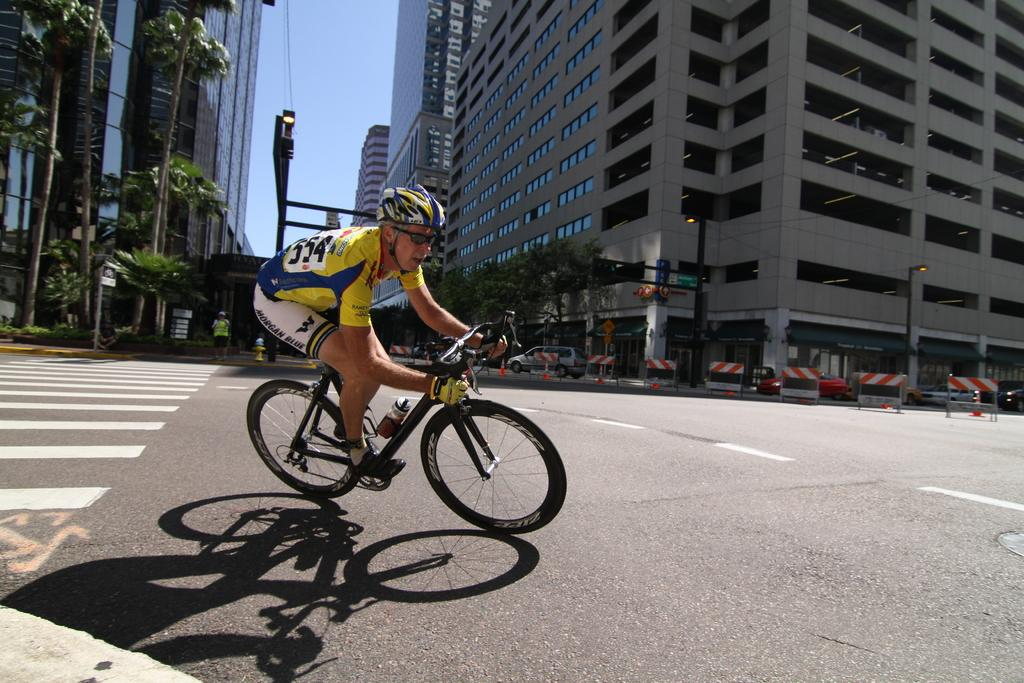What is the man in the image doing? The man is riding a bicycle in the image. What can be seen in the background of the image? There are buildings, poles, trees, barricades, cars, and a person in the background of the image. What type of pencil does the expert use to draw the chain in the image? There is no expert, pencil, or chain present in the image. 